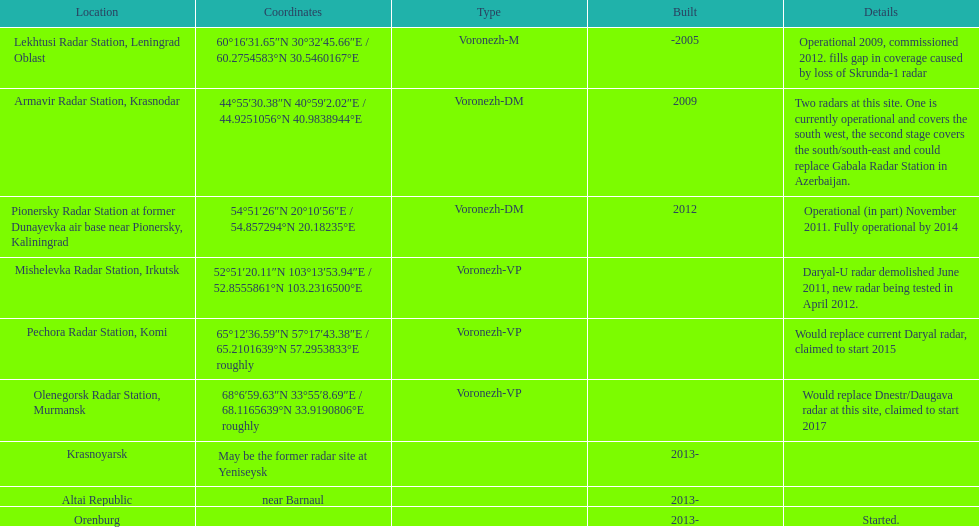Could you help me parse every detail presented in this table? {'header': ['Location', 'Coordinates', 'Type', 'Built', 'Details'], 'rows': [['Lekhtusi Radar Station, Leningrad Oblast', '60°16′31.65″N 30°32′45.66″E\ufeff / \ufeff60.2754583°N 30.5460167°E', 'Voronezh-M', '-2005', 'Operational 2009, commissioned 2012. fills gap in coverage caused by loss of Skrunda-1 radar'], ['Armavir Radar Station, Krasnodar', '44°55′30.38″N 40°59′2.02″E\ufeff / \ufeff44.9251056°N 40.9838944°E', 'Voronezh-DM', '2009', 'Two radars at this site. One is currently operational and covers the south west, the second stage covers the south/south-east and could replace Gabala Radar Station in Azerbaijan.'], ['Pionersky Radar Station at former Dunayevka air base near Pionersky, Kaliningrad', '54°51′26″N 20°10′56″E\ufeff / \ufeff54.857294°N 20.18235°E', 'Voronezh-DM', '2012', 'Operational (in part) November 2011. Fully operational by 2014'], ['Mishelevka Radar Station, Irkutsk', '52°51′20.11″N 103°13′53.94″E\ufeff / \ufeff52.8555861°N 103.2316500°E', 'Voronezh-VP', '', 'Daryal-U radar demolished June 2011, new radar being tested in April 2012.'], ['Pechora Radar Station, Komi', '65°12′36.59″N 57°17′43.38″E\ufeff / \ufeff65.2101639°N 57.2953833°E roughly', 'Voronezh-VP', '', 'Would replace current Daryal radar, claimed to start 2015'], ['Olenegorsk Radar Station, Murmansk', '68°6′59.63″N 33°55′8.69″E\ufeff / \ufeff68.1165639°N 33.9190806°E roughly', 'Voronezh-VP', '', 'Would replace Dnestr/Daugava radar at this site, claimed to start 2017'], ['Krasnoyarsk', 'May be the former radar site at Yeniseysk', '', '2013-', ''], ['Altai Republic', 'near Barnaul', '', '2013-', ''], ['Orenburg', '', '', '2013-', 'Started.']]} 2754583°n 3 Lekhtusi Radar Station, Leningrad Oblast. 